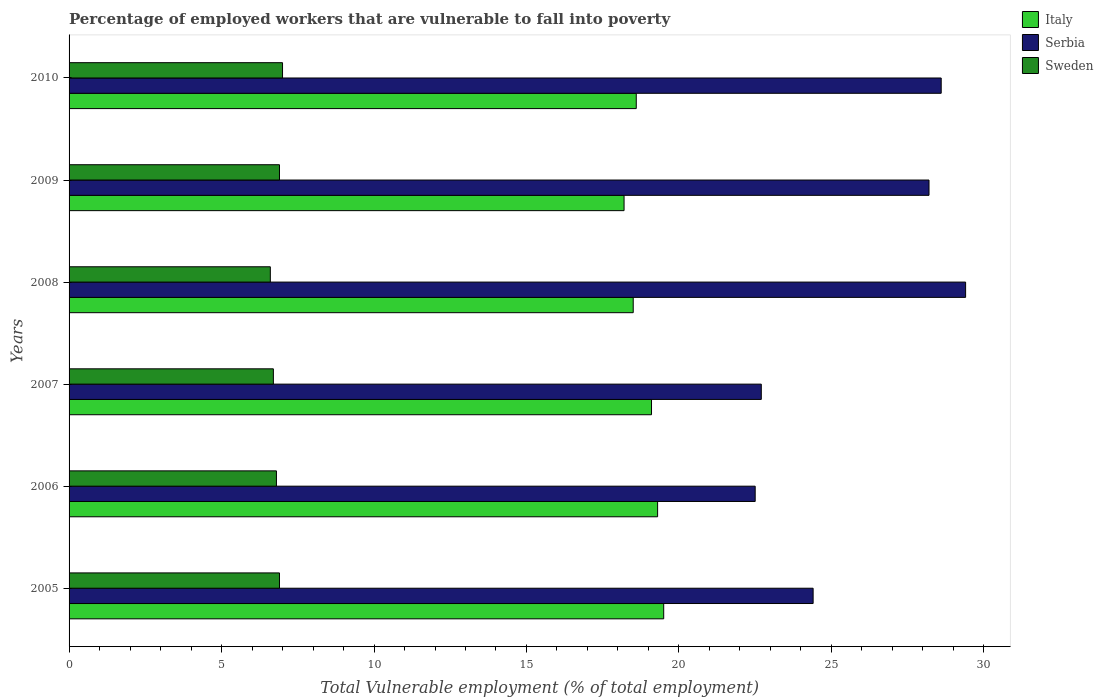How many different coloured bars are there?
Ensure brevity in your answer.  3. Are the number of bars per tick equal to the number of legend labels?
Your response must be concise. Yes. How many bars are there on the 4th tick from the top?
Offer a terse response. 3. In how many cases, is the number of bars for a given year not equal to the number of legend labels?
Your answer should be compact. 0. What is the percentage of employed workers who are vulnerable to fall into poverty in Italy in 2006?
Your answer should be very brief. 19.3. Across all years, what is the minimum percentage of employed workers who are vulnerable to fall into poverty in Serbia?
Provide a short and direct response. 22.5. What is the total percentage of employed workers who are vulnerable to fall into poverty in Serbia in the graph?
Provide a succinct answer. 155.8. What is the difference between the percentage of employed workers who are vulnerable to fall into poverty in Serbia in 2005 and that in 2007?
Your response must be concise. 1.7. What is the difference between the percentage of employed workers who are vulnerable to fall into poverty in Sweden in 2010 and the percentage of employed workers who are vulnerable to fall into poverty in Serbia in 2008?
Offer a terse response. -22.4. What is the average percentage of employed workers who are vulnerable to fall into poverty in Italy per year?
Your answer should be very brief. 18.87. In the year 2007, what is the difference between the percentage of employed workers who are vulnerable to fall into poverty in Serbia and percentage of employed workers who are vulnerable to fall into poverty in Italy?
Offer a very short reply. 3.6. In how many years, is the percentage of employed workers who are vulnerable to fall into poverty in Serbia greater than 8 %?
Keep it short and to the point. 6. What is the ratio of the percentage of employed workers who are vulnerable to fall into poverty in Sweden in 2005 to that in 2006?
Offer a very short reply. 1.01. What is the difference between the highest and the second highest percentage of employed workers who are vulnerable to fall into poverty in Serbia?
Your answer should be compact. 0.8. What is the difference between the highest and the lowest percentage of employed workers who are vulnerable to fall into poverty in Italy?
Provide a succinct answer. 1.3. What does the 3rd bar from the top in 2008 represents?
Provide a succinct answer. Italy. What does the 3rd bar from the bottom in 2005 represents?
Keep it short and to the point. Sweden. Is it the case that in every year, the sum of the percentage of employed workers who are vulnerable to fall into poverty in Italy and percentage of employed workers who are vulnerable to fall into poverty in Serbia is greater than the percentage of employed workers who are vulnerable to fall into poverty in Sweden?
Your answer should be very brief. Yes. Does the graph contain any zero values?
Make the answer very short. No. Where does the legend appear in the graph?
Your answer should be compact. Top right. How are the legend labels stacked?
Keep it short and to the point. Vertical. What is the title of the graph?
Your answer should be compact. Percentage of employed workers that are vulnerable to fall into poverty. What is the label or title of the X-axis?
Your response must be concise. Total Vulnerable employment (% of total employment). What is the Total Vulnerable employment (% of total employment) of Serbia in 2005?
Your response must be concise. 24.4. What is the Total Vulnerable employment (% of total employment) of Sweden in 2005?
Your answer should be compact. 6.9. What is the Total Vulnerable employment (% of total employment) in Italy in 2006?
Offer a terse response. 19.3. What is the Total Vulnerable employment (% of total employment) in Serbia in 2006?
Offer a terse response. 22.5. What is the Total Vulnerable employment (% of total employment) of Sweden in 2006?
Provide a short and direct response. 6.8. What is the Total Vulnerable employment (% of total employment) in Italy in 2007?
Provide a succinct answer. 19.1. What is the Total Vulnerable employment (% of total employment) in Serbia in 2007?
Offer a terse response. 22.7. What is the Total Vulnerable employment (% of total employment) of Sweden in 2007?
Provide a succinct answer. 6.7. What is the Total Vulnerable employment (% of total employment) of Italy in 2008?
Your answer should be compact. 18.5. What is the Total Vulnerable employment (% of total employment) of Serbia in 2008?
Provide a short and direct response. 29.4. What is the Total Vulnerable employment (% of total employment) in Sweden in 2008?
Keep it short and to the point. 6.6. What is the Total Vulnerable employment (% of total employment) in Italy in 2009?
Make the answer very short. 18.2. What is the Total Vulnerable employment (% of total employment) of Serbia in 2009?
Your answer should be compact. 28.2. What is the Total Vulnerable employment (% of total employment) in Sweden in 2009?
Offer a terse response. 6.9. What is the Total Vulnerable employment (% of total employment) of Italy in 2010?
Offer a very short reply. 18.6. What is the Total Vulnerable employment (% of total employment) in Serbia in 2010?
Your response must be concise. 28.6. Across all years, what is the maximum Total Vulnerable employment (% of total employment) in Italy?
Your answer should be very brief. 19.5. Across all years, what is the maximum Total Vulnerable employment (% of total employment) in Serbia?
Provide a short and direct response. 29.4. Across all years, what is the maximum Total Vulnerable employment (% of total employment) of Sweden?
Your answer should be very brief. 7. Across all years, what is the minimum Total Vulnerable employment (% of total employment) in Italy?
Ensure brevity in your answer.  18.2. Across all years, what is the minimum Total Vulnerable employment (% of total employment) of Serbia?
Provide a succinct answer. 22.5. Across all years, what is the minimum Total Vulnerable employment (% of total employment) of Sweden?
Give a very brief answer. 6.6. What is the total Total Vulnerable employment (% of total employment) of Italy in the graph?
Give a very brief answer. 113.2. What is the total Total Vulnerable employment (% of total employment) in Serbia in the graph?
Your answer should be compact. 155.8. What is the total Total Vulnerable employment (% of total employment) of Sweden in the graph?
Offer a terse response. 40.9. What is the difference between the Total Vulnerable employment (% of total employment) of Italy in 2005 and that in 2006?
Offer a very short reply. 0.2. What is the difference between the Total Vulnerable employment (% of total employment) of Serbia in 2005 and that in 2007?
Give a very brief answer. 1.7. What is the difference between the Total Vulnerable employment (% of total employment) of Italy in 2005 and that in 2008?
Your answer should be very brief. 1. What is the difference between the Total Vulnerable employment (% of total employment) in Serbia in 2005 and that in 2009?
Offer a very short reply. -3.8. What is the difference between the Total Vulnerable employment (% of total employment) in Sweden in 2005 and that in 2010?
Ensure brevity in your answer.  -0.1. What is the difference between the Total Vulnerable employment (% of total employment) of Sweden in 2006 and that in 2008?
Keep it short and to the point. 0.2. What is the difference between the Total Vulnerable employment (% of total employment) in Italy in 2006 and that in 2009?
Offer a terse response. 1.1. What is the difference between the Total Vulnerable employment (% of total employment) of Sweden in 2006 and that in 2009?
Provide a short and direct response. -0.1. What is the difference between the Total Vulnerable employment (% of total employment) of Sweden in 2006 and that in 2010?
Give a very brief answer. -0.2. What is the difference between the Total Vulnerable employment (% of total employment) of Italy in 2007 and that in 2008?
Ensure brevity in your answer.  0.6. What is the difference between the Total Vulnerable employment (% of total employment) in Sweden in 2007 and that in 2008?
Your answer should be very brief. 0.1. What is the difference between the Total Vulnerable employment (% of total employment) in Serbia in 2007 and that in 2009?
Provide a succinct answer. -5.5. What is the difference between the Total Vulnerable employment (% of total employment) in Italy in 2007 and that in 2010?
Offer a very short reply. 0.5. What is the difference between the Total Vulnerable employment (% of total employment) of Sweden in 2007 and that in 2010?
Your answer should be very brief. -0.3. What is the difference between the Total Vulnerable employment (% of total employment) of Italy in 2008 and that in 2009?
Your response must be concise. 0.3. What is the difference between the Total Vulnerable employment (% of total employment) in Sweden in 2008 and that in 2009?
Offer a very short reply. -0.3. What is the difference between the Total Vulnerable employment (% of total employment) of Serbia in 2008 and that in 2010?
Ensure brevity in your answer.  0.8. What is the difference between the Total Vulnerable employment (% of total employment) of Sweden in 2008 and that in 2010?
Provide a short and direct response. -0.4. What is the difference between the Total Vulnerable employment (% of total employment) in Italy in 2009 and that in 2010?
Make the answer very short. -0.4. What is the difference between the Total Vulnerable employment (% of total employment) in Serbia in 2009 and that in 2010?
Make the answer very short. -0.4. What is the difference between the Total Vulnerable employment (% of total employment) of Sweden in 2009 and that in 2010?
Make the answer very short. -0.1. What is the difference between the Total Vulnerable employment (% of total employment) in Italy in 2005 and the Total Vulnerable employment (% of total employment) in Serbia in 2006?
Offer a very short reply. -3. What is the difference between the Total Vulnerable employment (% of total employment) in Italy in 2005 and the Total Vulnerable employment (% of total employment) in Sweden in 2006?
Keep it short and to the point. 12.7. What is the difference between the Total Vulnerable employment (% of total employment) of Serbia in 2005 and the Total Vulnerable employment (% of total employment) of Sweden in 2006?
Ensure brevity in your answer.  17.6. What is the difference between the Total Vulnerable employment (% of total employment) of Serbia in 2005 and the Total Vulnerable employment (% of total employment) of Sweden in 2008?
Your answer should be very brief. 17.8. What is the difference between the Total Vulnerable employment (% of total employment) in Italy in 2005 and the Total Vulnerable employment (% of total employment) in Sweden in 2009?
Keep it short and to the point. 12.6. What is the difference between the Total Vulnerable employment (% of total employment) in Italy in 2005 and the Total Vulnerable employment (% of total employment) in Serbia in 2010?
Make the answer very short. -9.1. What is the difference between the Total Vulnerable employment (% of total employment) of Italy in 2005 and the Total Vulnerable employment (% of total employment) of Sweden in 2010?
Your response must be concise. 12.5. What is the difference between the Total Vulnerable employment (% of total employment) in Italy in 2006 and the Total Vulnerable employment (% of total employment) in Sweden in 2007?
Provide a short and direct response. 12.6. What is the difference between the Total Vulnerable employment (% of total employment) of Serbia in 2006 and the Total Vulnerable employment (% of total employment) of Sweden in 2008?
Provide a succinct answer. 15.9. What is the difference between the Total Vulnerable employment (% of total employment) of Italy in 2006 and the Total Vulnerable employment (% of total employment) of Serbia in 2009?
Ensure brevity in your answer.  -8.9. What is the difference between the Total Vulnerable employment (% of total employment) in Italy in 2006 and the Total Vulnerable employment (% of total employment) in Sweden in 2009?
Your response must be concise. 12.4. What is the difference between the Total Vulnerable employment (% of total employment) in Italy in 2006 and the Total Vulnerable employment (% of total employment) in Sweden in 2010?
Provide a short and direct response. 12.3. What is the difference between the Total Vulnerable employment (% of total employment) of Serbia in 2006 and the Total Vulnerable employment (% of total employment) of Sweden in 2010?
Offer a terse response. 15.5. What is the difference between the Total Vulnerable employment (% of total employment) of Italy in 2007 and the Total Vulnerable employment (% of total employment) of Serbia in 2009?
Provide a short and direct response. -9.1. What is the difference between the Total Vulnerable employment (% of total employment) in Italy in 2007 and the Total Vulnerable employment (% of total employment) in Sweden in 2009?
Provide a succinct answer. 12.2. What is the difference between the Total Vulnerable employment (% of total employment) of Italy in 2007 and the Total Vulnerable employment (% of total employment) of Serbia in 2010?
Offer a terse response. -9.5. What is the difference between the Total Vulnerable employment (% of total employment) of Italy in 2007 and the Total Vulnerable employment (% of total employment) of Sweden in 2010?
Your answer should be compact. 12.1. What is the difference between the Total Vulnerable employment (% of total employment) of Serbia in 2007 and the Total Vulnerable employment (% of total employment) of Sweden in 2010?
Your answer should be very brief. 15.7. What is the difference between the Total Vulnerable employment (% of total employment) of Italy in 2008 and the Total Vulnerable employment (% of total employment) of Sweden in 2009?
Provide a short and direct response. 11.6. What is the difference between the Total Vulnerable employment (% of total employment) in Italy in 2008 and the Total Vulnerable employment (% of total employment) in Serbia in 2010?
Offer a very short reply. -10.1. What is the difference between the Total Vulnerable employment (% of total employment) in Italy in 2008 and the Total Vulnerable employment (% of total employment) in Sweden in 2010?
Ensure brevity in your answer.  11.5. What is the difference between the Total Vulnerable employment (% of total employment) of Serbia in 2008 and the Total Vulnerable employment (% of total employment) of Sweden in 2010?
Offer a terse response. 22.4. What is the difference between the Total Vulnerable employment (% of total employment) in Italy in 2009 and the Total Vulnerable employment (% of total employment) in Serbia in 2010?
Ensure brevity in your answer.  -10.4. What is the difference between the Total Vulnerable employment (% of total employment) of Serbia in 2009 and the Total Vulnerable employment (% of total employment) of Sweden in 2010?
Provide a succinct answer. 21.2. What is the average Total Vulnerable employment (% of total employment) of Italy per year?
Ensure brevity in your answer.  18.87. What is the average Total Vulnerable employment (% of total employment) of Serbia per year?
Give a very brief answer. 25.97. What is the average Total Vulnerable employment (% of total employment) of Sweden per year?
Give a very brief answer. 6.82. In the year 2005, what is the difference between the Total Vulnerable employment (% of total employment) of Italy and Total Vulnerable employment (% of total employment) of Sweden?
Ensure brevity in your answer.  12.6. In the year 2005, what is the difference between the Total Vulnerable employment (% of total employment) of Serbia and Total Vulnerable employment (% of total employment) of Sweden?
Your answer should be very brief. 17.5. In the year 2006, what is the difference between the Total Vulnerable employment (% of total employment) in Italy and Total Vulnerable employment (% of total employment) in Serbia?
Your answer should be compact. -3.2. In the year 2007, what is the difference between the Total Vulnerable employment (% of total employment) in Italy and Total Vulnerable employment (% of total employment) in Serbia?
Your response must be concise. -3.6. In the year 2007, what is the difference between the Total Vulnerable employment (% of total employment) in Serbia and Total Vulnerable employment (% of total employment) in Sweden?
Ensure brevity in your answer.  16. In the year 2008, what is the difference between the Total Vulnerable employment (% of total employment) in Italy and Total Vulnerable employment (% of total employment) in Serbia?
Offer a very short reply. -10.9. In the year 2008, what is the difference between the Total Vulnerable employment (% of total employment) in Serbia and Total Vulnerable employment (% of total employment) in Sweden?
Offer a very short reply. 22.8. In the year 2009, what is the difference between the Total Vulnerable employment (% of total employment) of Italy and Total Vulnerable employment (% of total employment) of Serbia?
Offer a very short reply. -10. In the year 2009, what is the difference between the Total Vulnerable employment (% of total employment) of Italy and Total Vulnerable employment (% of total employment) of Sweden?
Ensure brevity in your answer.  11.3. In the year 2009, what is the difference between the Total Vulnerable employment (% of total employment) of Serbia and Total Vulnerable employment (% of total employment) of Sweden?
Your response must be concise. 21.3. In the year 2010, what is the difference between the Total Vulnerable employment (% of total employment) in Serbia and Total Vulnerable employment (% of total employment) in Sweden?
Offer a terse response. 21.6. What is the ratio of the Total Vulnerable employment (% of total employment) of Italy in 2005 to that in 2006?
Provide a succinct answer. 1.01. What is the ratio of the Total Vulnerable employment (% of total employment) in Serbia in 2005 to that in 2006?
Your response must be concise. 1.08. What is the ratio of the Total Vulnerable employment (% of total employment) in Sweden in 2005 to that in 2006?
Your answer should be compact. 1.01. What is the ratio of the Total Vulnerable employment (% of total employment) of Italy in 2005 to that in 2007?
Give a very brief answer. 1.02. What is the ratio of the Total Vulnerable employment (% of total employment) in Serbia in 2005 to that in 2007?
Provide a succinct answer. 1.07. What is the ratio of the Total Vulnerable employment (% of total employment) of Sweden in 2005 to that in 2007?
Make the answer very short. 1.03. What is the ratio of the Total Vulnerable employment (% of total employment) of Italy in 2005 to that in 2008?
Offer a very short reply. 1.05. What is the ratio of the Total Vulnerable employment (% of total employment) of Serbia in 2005 to that in 2008?
Provide a succinct answer. 0.83. What is the ratio of the Total Vulnerable employment (% of total employment) in Sweden in 2005 to that in 2008?
Your answer should be compact. 1.05. What is the ratio of the Total Vulnerable employment (% of total employment) in Italy in 2005 to that in 2009?
Give a very brief answer. 1.07. What is the ratio of the Total Vulnerable employment (% of total employment) in Serbia in 2005 to that in 2009?
Your answer should be very brief. 0.87. What is the ratio of the Total Vulnerable employment (% of total employment) of Sweden in 2005 to that in 2009?
Give a very brief answer. 1. What is the ratio of the Total Vulnerable employment (% of total employment) in Italy in 2005 to that in 2010?
Provide a succinct answer. 1.05. What is the ratio of the Total Vulnerable employment (% of total employment) in Serbia in 2005 to that in 2010?
Provide a succinct answer. 0.85. What is the ratio of the Total Vulnerable employment (% of total employment) in Sweden in 2005 to that in 2010?
Make the answer very short. 0.99. What is the ratio of the Total Vulnerable employment (% of total employment) in Italy in 2006 to that in 2007?
Offer a terse response. 1.01. What is the ratio of the Total Vulnerable employment (% of total employment) of Sweden in 2006 to that in 2007?
Ensure brevity in your answer.  1.01. What is the ratio of the Total Vulnerable employment (% of total employment) of Italy in 2006 to that in 2008?
Your answer should be compact. 1.04. What is the ratio of the Total Vulnerable employment (% of total employment) of Serbia in 2006 to that in 2008?
Offer a very short reply. 0.77. What is the ratio of the Total Vulnerable employment (% of total employment) of Sweden in 2006 to that in 2008?
Offer a terse response. 1.03. What is the ratio of the Total Vulnerable employment (% of total employment) in Italy in 2006 to that in 2009?
Ensure brevity in your answer.  1.06. What is the ratio of the Total Vulnerable employment (% of total employment) in Serbia in 2006 to that in 2009?
Offer a very short reply. 0.8. What is the ratio of the Total Vulnerable employment (% of total employment) in Sweden in 2006 to that in 2009?
Give a very brief answer. 0.99. What is the ratio of the Total Vulnerable employment (% of total employment) in Italy in 2006 to that in 2010?
Your answer should be compact. 1.04. What is the ratio of the Total Vulnerable employment (% of total employment) in Serbia in 2006 to that in 2010?
Your response must be concise. 0.79. What is the ratio of the Total Vulnerable employment (% of total employment) in Sweden in 2006 to that in 2010?
Give a very brief answer. 0.97. What is the ratio of the Total Vulnerable employment (% of total employment) of Italy in 2007 to that in 2008?
Your answer should be compact. 1.03. What is the ratio of the Total Vulnerable employment (% of total employment) of Serbia in 2007 to that in 2008?
Your answer should be compact. 0.77. What is the ratio of the Total Vulnerable employment (% of total employment) in Sweden in 2007 to that in 2008?
Give a very brief answer. 1.02. What is the ratio of the Total Vulnerable employment (% of total employment) in Italy in 2007 to that in 2009?
Your response must be concise. 1.05. What is the ratio of the Total Vulnerable employment (% of total employment) in Serbia in 2007 to that in 2009?
Offer a very short reply. 0.81. What is the ratio of the Total Vulnerable employment (% of total employment) in Italy in 2007 to that in 2010?
Ensure brevity in your answer.  1.03. What is the ratio of the Total Vulnerable employment (% of total employment) of Serbia in 2007 to that in 2010?
Keep it short and to the point. 0.79. What is the ratio of the Total Vulnerable employment (% of total employment) of Sweden in 2007 to that in 2010?
Offer a terse response. 0.96. What is the ratio of the Total Vulnerable employment (% of total employment) of Italy in 2008 to that in 2009?
Make the answer very short. 1.02. What is the ratio of the Total Vulnerable employment (% of total employment) in Serbia in 2008 to that in 2009?
Offer a terse response. 1.04. What is the ratio of the Total Vulnerable employment (% of total employment) of Sweden in 2008 to that in 2009?
Make the answer very short. 0.96. What is the ratio of the Total Vulnerable employment (% of total employment) of Italy in 2008 to that in 2010?
Your response must be concise. 0.99. What is the ratio of the Total Vulnerable employment (% of total employment) in Serbia in 2008 to that in 2010?
Make the answer very short. 1.03. What is the ratio of the Total Vulnerable employment (% of total employment) of Sweden in 2008 to that in 2010?
Your answer should be compact. 0.94. What is the ratio of the Total Vulnerable employment (% of total employment) of Italy in 2009 to that in 2010?
Make the answer very short. 0.98. What is the ratio of the Total Vulnerable employment (% of total employment) in Serbia in 2009 to that in 2010?
Your answer should be very brief. 0.99. What is the ratio of the Total Vulnerable employment (% of total employment) of Sweden in 2009 to that in 2010?
Ensure brevity in your answer.  0.99. What is the difference between the highest and the second highest Total Vulnerable employment (% of total employment) of Italy?
Make the answer very short. 0.2. What is the difference between the highest and the lowest Total Vulnerable employment (% of total employment) of Serbia?
Offer a very short reply. 6.9. 